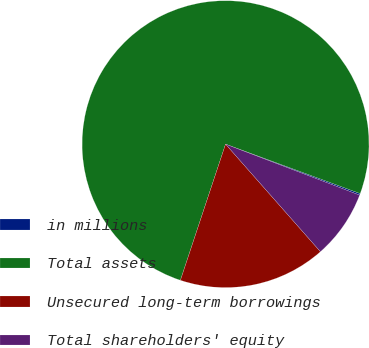Convert chart to OTSL. <chart><loc_0><loc_0><loc_500><loc_500><pie_chart><fcel>in millions<fcel>Total assets<fcel>Unsecured long-term borrowings<fcel>Total shareholders' equity<nl><fcel>0.18%<fcel>75.51%<fcel>16.6%<fcel>7.71%<nl></chart> 